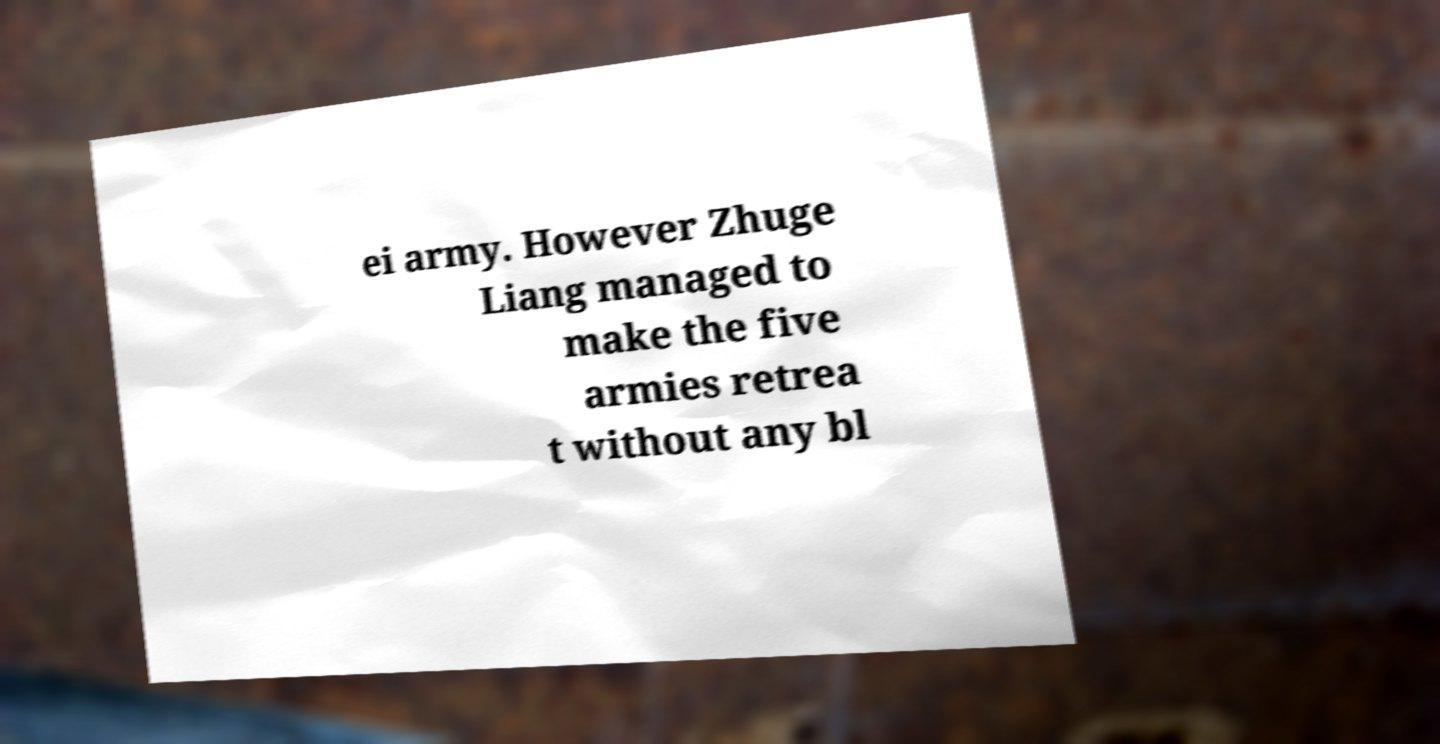For documentation purposes, I need the text within this image transcribed. Could you provide that? ei army. However Zhuge Liang managed to make the five armies retrea t without any bl 